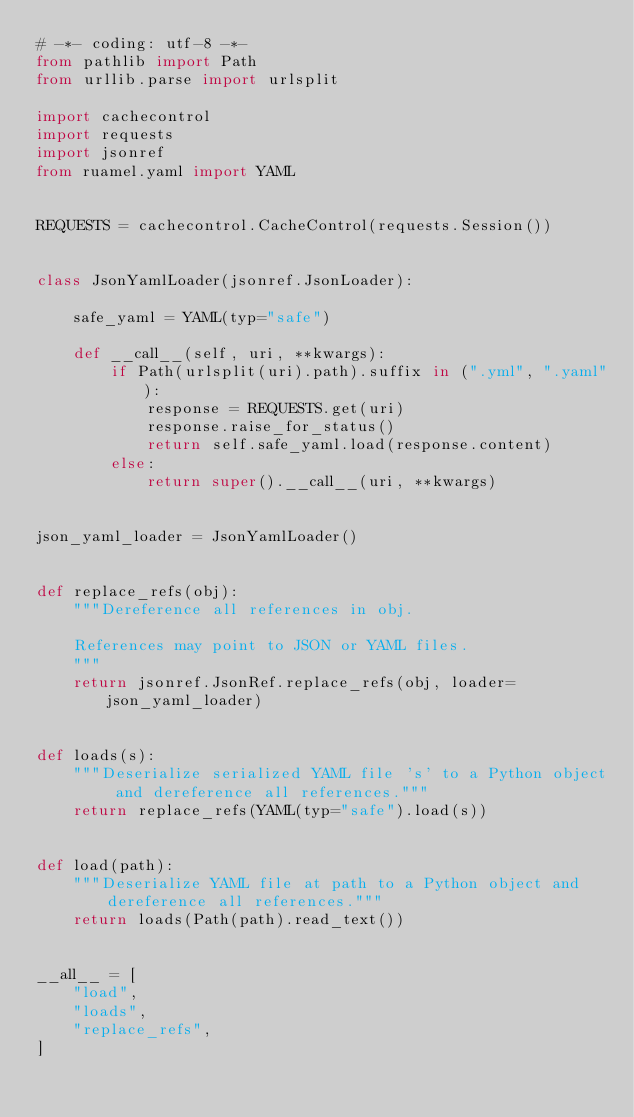Convert code to text. <code><loc_0><loc_0><loc_500><loc_500><_Python_># -*- coding: utf-8 -*-
from pathlib import Path
from urllib.parse import urlsplit

import cachecontrol
import requests
import jsonref
from ruamel.yaml import YAML


REQUESTS = cachecontrol.CacheControl(requests.Session())


class JsonYamlLoader(jsonref.JsonLoader):

    safe_yaml = YAML(typ="safe")

    def __call__(self, uri, **kwargs):
        if Path(urlsplit(uri).path).suffix in (".yml", ".yaml"):
            response = REQUESTS.get(uri)
            response.raise_for_status()
            return self.safe_yaml.load(response.content)
        else:
            return super().__call__(uri, **kwargs)


json_yaml_loader = JsonYamlLoader()


def replace_refs(obj):
    """Dereference all references in obj.

    References may point to JSON or YAML files.
    """
    return jsonref.JsonRef.replace_refs(obj, loader=json_yaml_loader)


def loads(s):
    """Deserialize serialized YAML file 's' to a Python object and dereference all references."""
    return replace_refs(YAML(typ="safe").load(s))


def load(path):
    """Deserialize YAML file at path to a Python object and dereference all references."""
    return loads(Path(path).read_text())


__all__ = [
    "load",
    "loads",
    "replace_refs",
]
</code> 